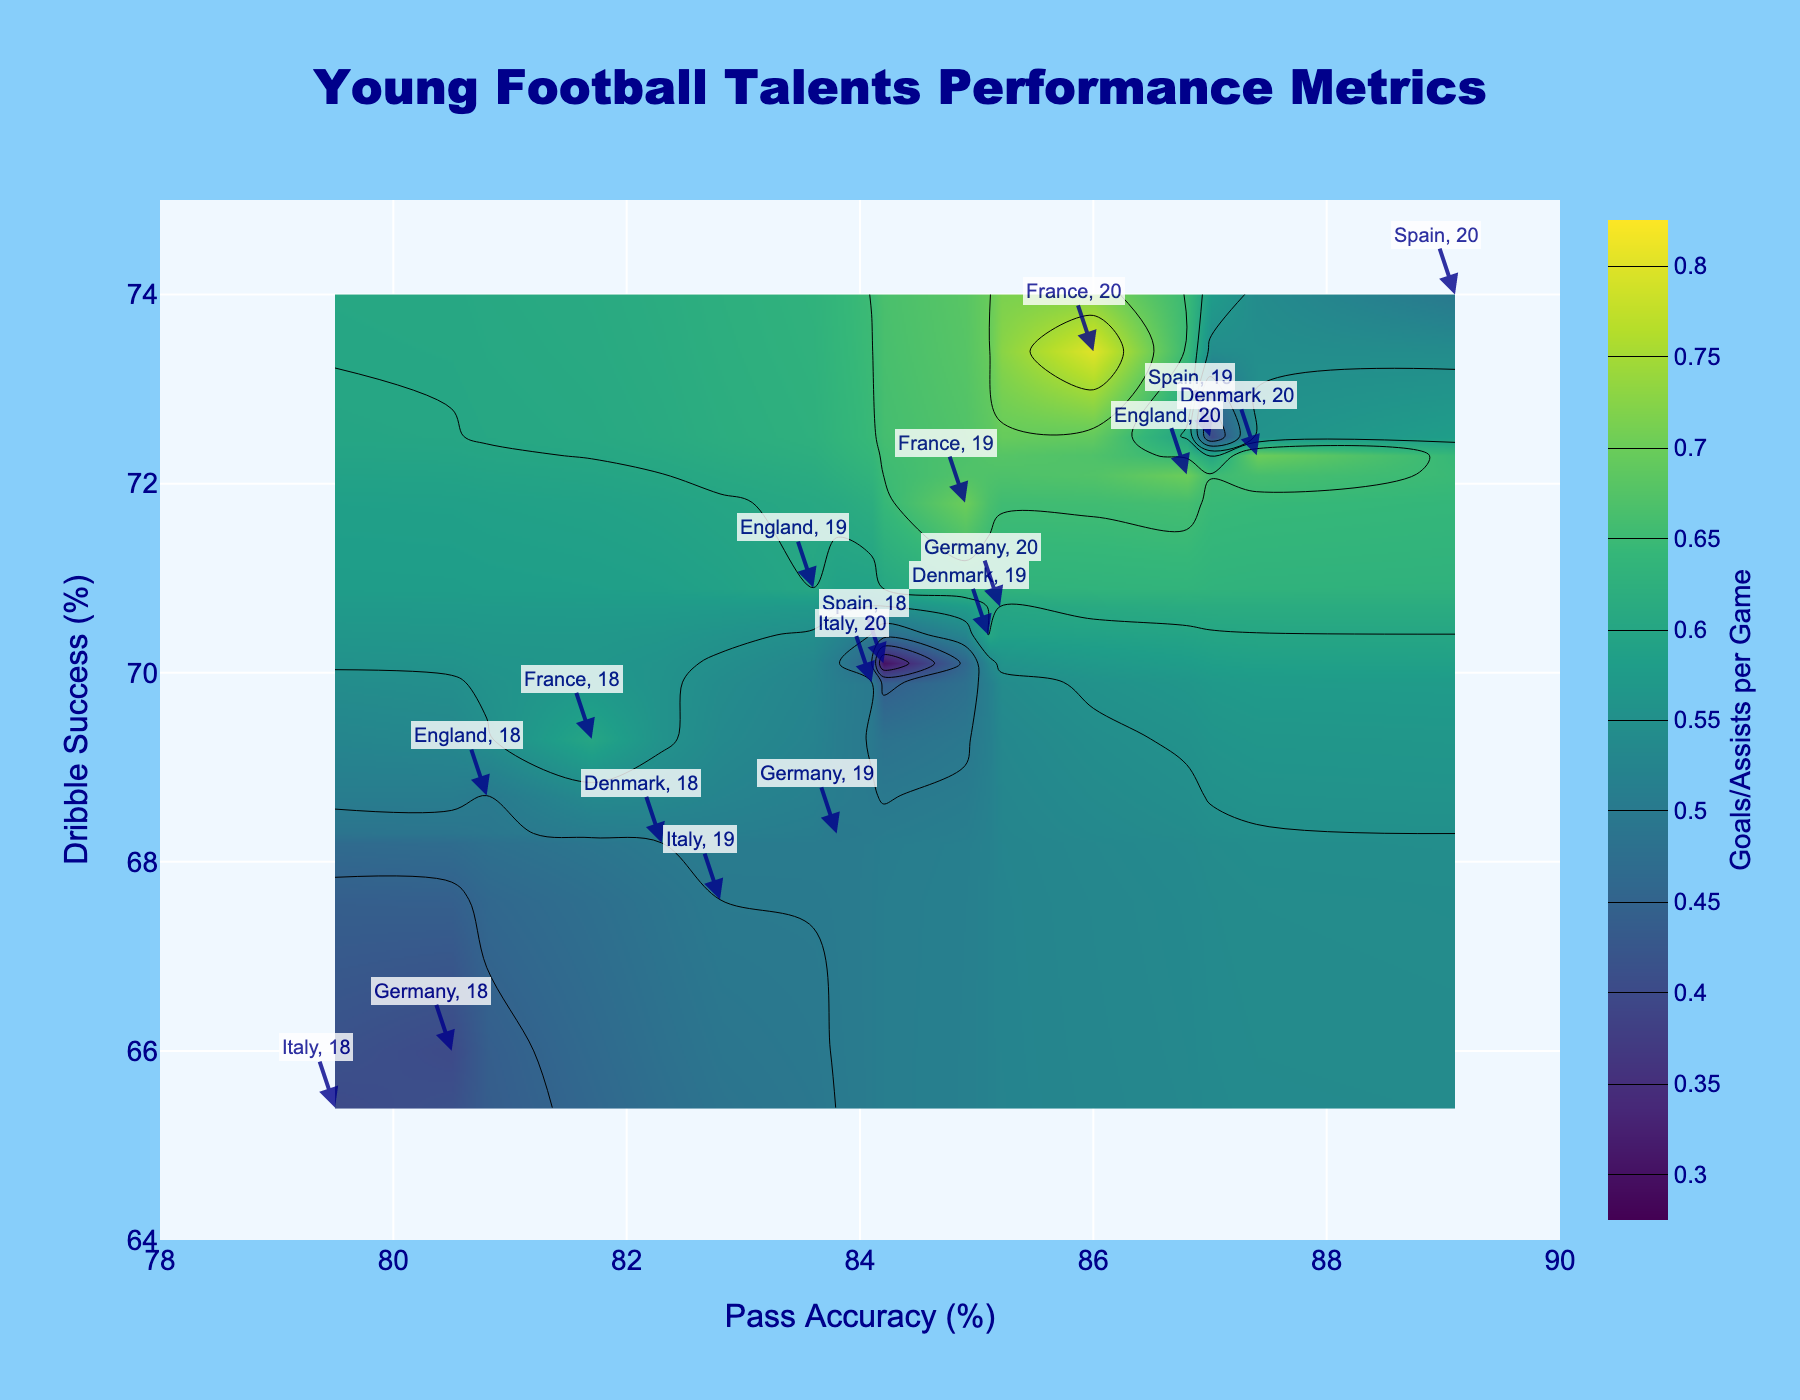What is the title of the plot? The title is written at the top center of the plot and usually provides a brief description of what the plot represents. In this case, it says "Young Football Talents Performance Metrics".
Answer: Young Football Talents Performance Metrics What is the range of the pass accuracy axis? The pass accuracy axis is labeled on the x-axis of the plot with numbers indicating the scale. The range is specified in the axis labels and ticks.
Answer: 78 to 90 How many data points are shown in the figure? Each data point in the plot represents a combination of pass accuracy and dribble success with a corresponding goals/assists per game value. By counting the annotations or markers, you can determine the total number.
Answer: 18 Which country’s 20-year-old players have the highest goals/assists per game? To identify this, look for the annotations of 20-year-old players and compare the values of goals/assists per game associated with them. The country with the highest value can be determined by examining the contours or colors in the plot.
Answer: France What is the difference in dribble success between the 18-year-old Spanish and Danish players? Identify the dribble success values for both 18-year-old players from Spain and Denmark by looking at their annotated points on the plot. Subtract the Spanish player's value from the Danish player's value.
Answer: -1.9 (Denmark: 68.2, Spain: 70.1, Difference: 68.2 - 70.1 = -1.9) Which age group shows the highest pass accuracy for English players? Find the annotations for English players and compare the pass accuracy values across different age groups. Determine which age group has the highest value.
Answer: 20-year-olds Is there a trend in goals/assists per game with increasing age for Italian players? Look at the annotations for Italian players and note the goals/assists per game values for different ages. Determine if there's a noticeable trend as the age increases.
Answer: Yes, it increases Between dribble success and pass accuracy, which metric shows a steeper increase when moving from 18-year-olds to 20-year-olds across all countries? Calculate the average increase in dribble success and pass accuracy from 18-year-olds to 20-year-olds for all countries and compare the two averages.
Answer: Pass accuracy Which age group has the lowest goals/assists per game among German players? Check the annotations for German players and compare the goals/assists per game values for different age groups to find the lowest.
Answer: 18-year-olds 